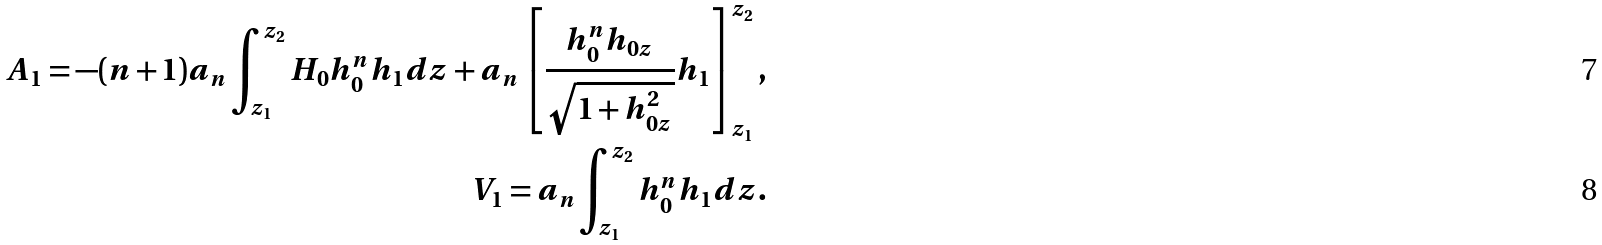<formula> <loc_0><loc_0><loc_500><loc_500>A _ { 1 } = - ( n + 1 ) a _ { n } \int _ { z _ { 1 } } ^ { z _ { 2 } } H _ { 0 } h _ { 0 } ^ { n } h _ { 1 } d z + a _ { n } \left [ \frac { h _ { 0 } ^ { n } h _ { 0 z } } { \sqrt { 1 + h _ { 0 z } ^ { 2 } } } h _ { 1 } \right ] _ { z _ { 1 } } ^ { z _ { 2 } } , \\ V _ { 1 } = a _ { n } \int _ { z _ { 1 } } ^ { z _ { 2 } } h _ { 0 } ^ { n } h _ { 1 } d z .</formula> 